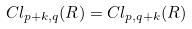<formula> <loc_0><loc_0><loc_500><loc_500>C l _ { p + k , q } ( R ) = C l _ { p , q + k } ( R )</formula> 